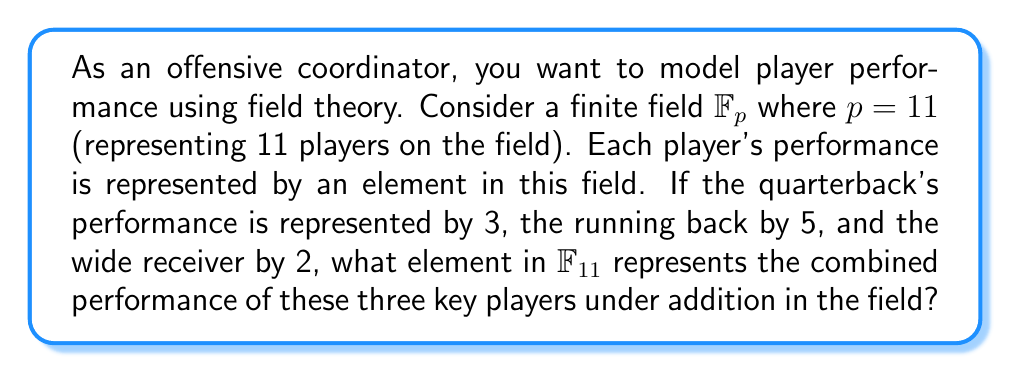Show me your answer to this math problem. To solve this problem, we need to understand the properties of finite fields and how to perform arithmetic operations in $\mathbb{F}_{11}$.

1) In $\mathbb{F}_{11}$, the elements are $\{0, 1, 2, ..., 10\}$.

2) Addition in $\mathbb{F}_{11}$ is performed modulo 11. This means we add the numbers as usual, but if the result is 11 or greater, we subtract 11 repeatedly until we get a number between 0 and 10.

3) The performances we need to combine are:
   - Quarterback: 3
   - Running back: 5
   - Wide receiver: 2

4) We add these numbers:

   $3 + 5 + 2 = 10$

5) Since 10 is already in $\mathbb{F}_{11}$ (it's less than 11), we don't need to perform any modulo operation.

Therefore, the combined performance is represented by 10 in $\mathbb{F}_{11}$.

This model allows us to represent complex interactions between players in a mathematical framework, which could be useful for analyzing team dynamics and optimizing play strategies.
Answer: 10 